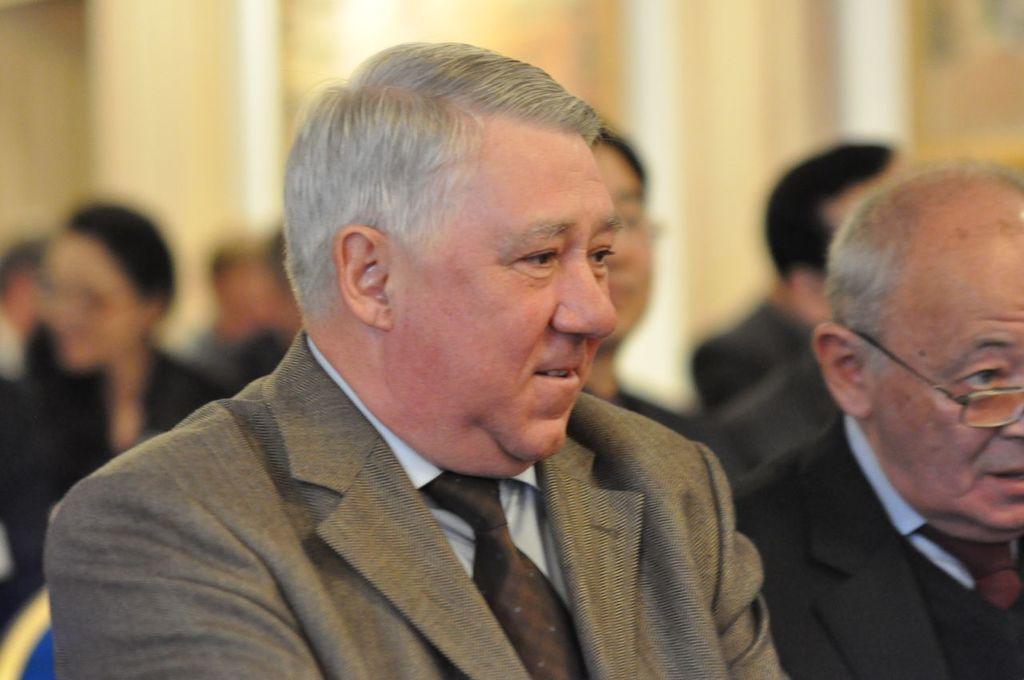Describe this image in one or two sentences. In this image in the foreground there are two persons and in the background there are a group of people, and the background looks like a wall. 